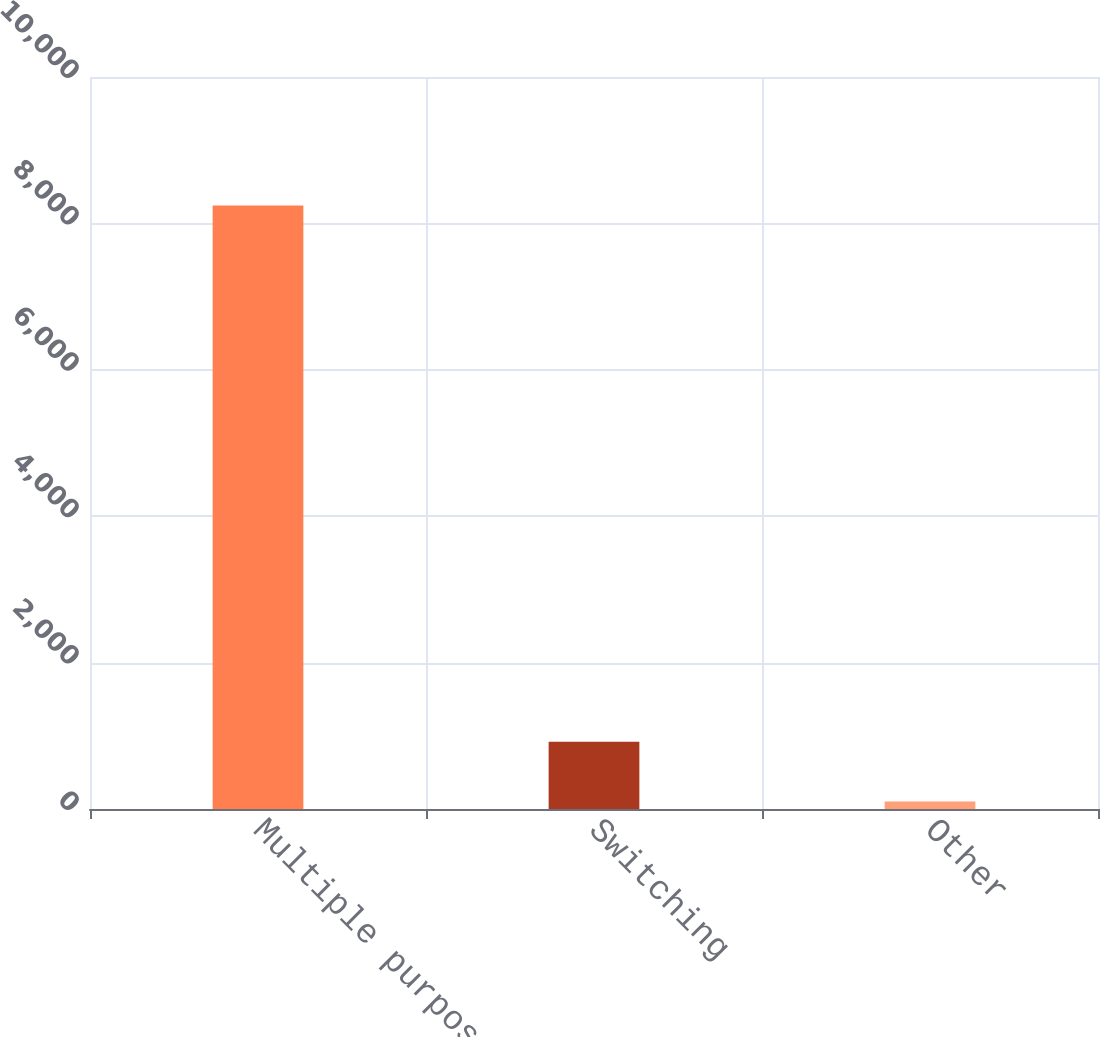Convert chart to OTSL. <chart><loc_0><loc_0><loc_500><loc_500><bar_chart><fcel>Multiple purpose<fcel>Switching<fcel>Other<nl><fcel>8244<fcel>918<fcel>104<nl></chart> 